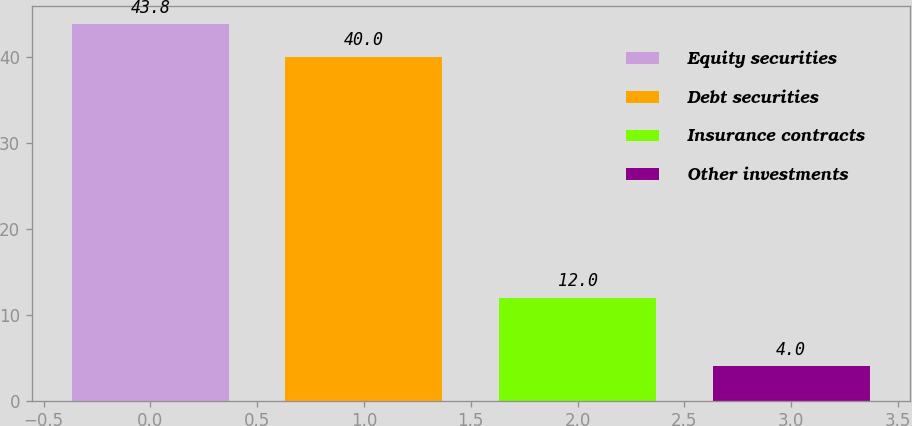Convert chart to OTSL. <chart><loc_0><loc_0><loc_500><loc_500><bar_chart><fcel>Equity securities<fcel>Debt securities<fcel>Insurance contracts<fcel>Other investments<nl><fcel>43.8<fcel>40<fcel>12<fcel>4<nl></chart> 